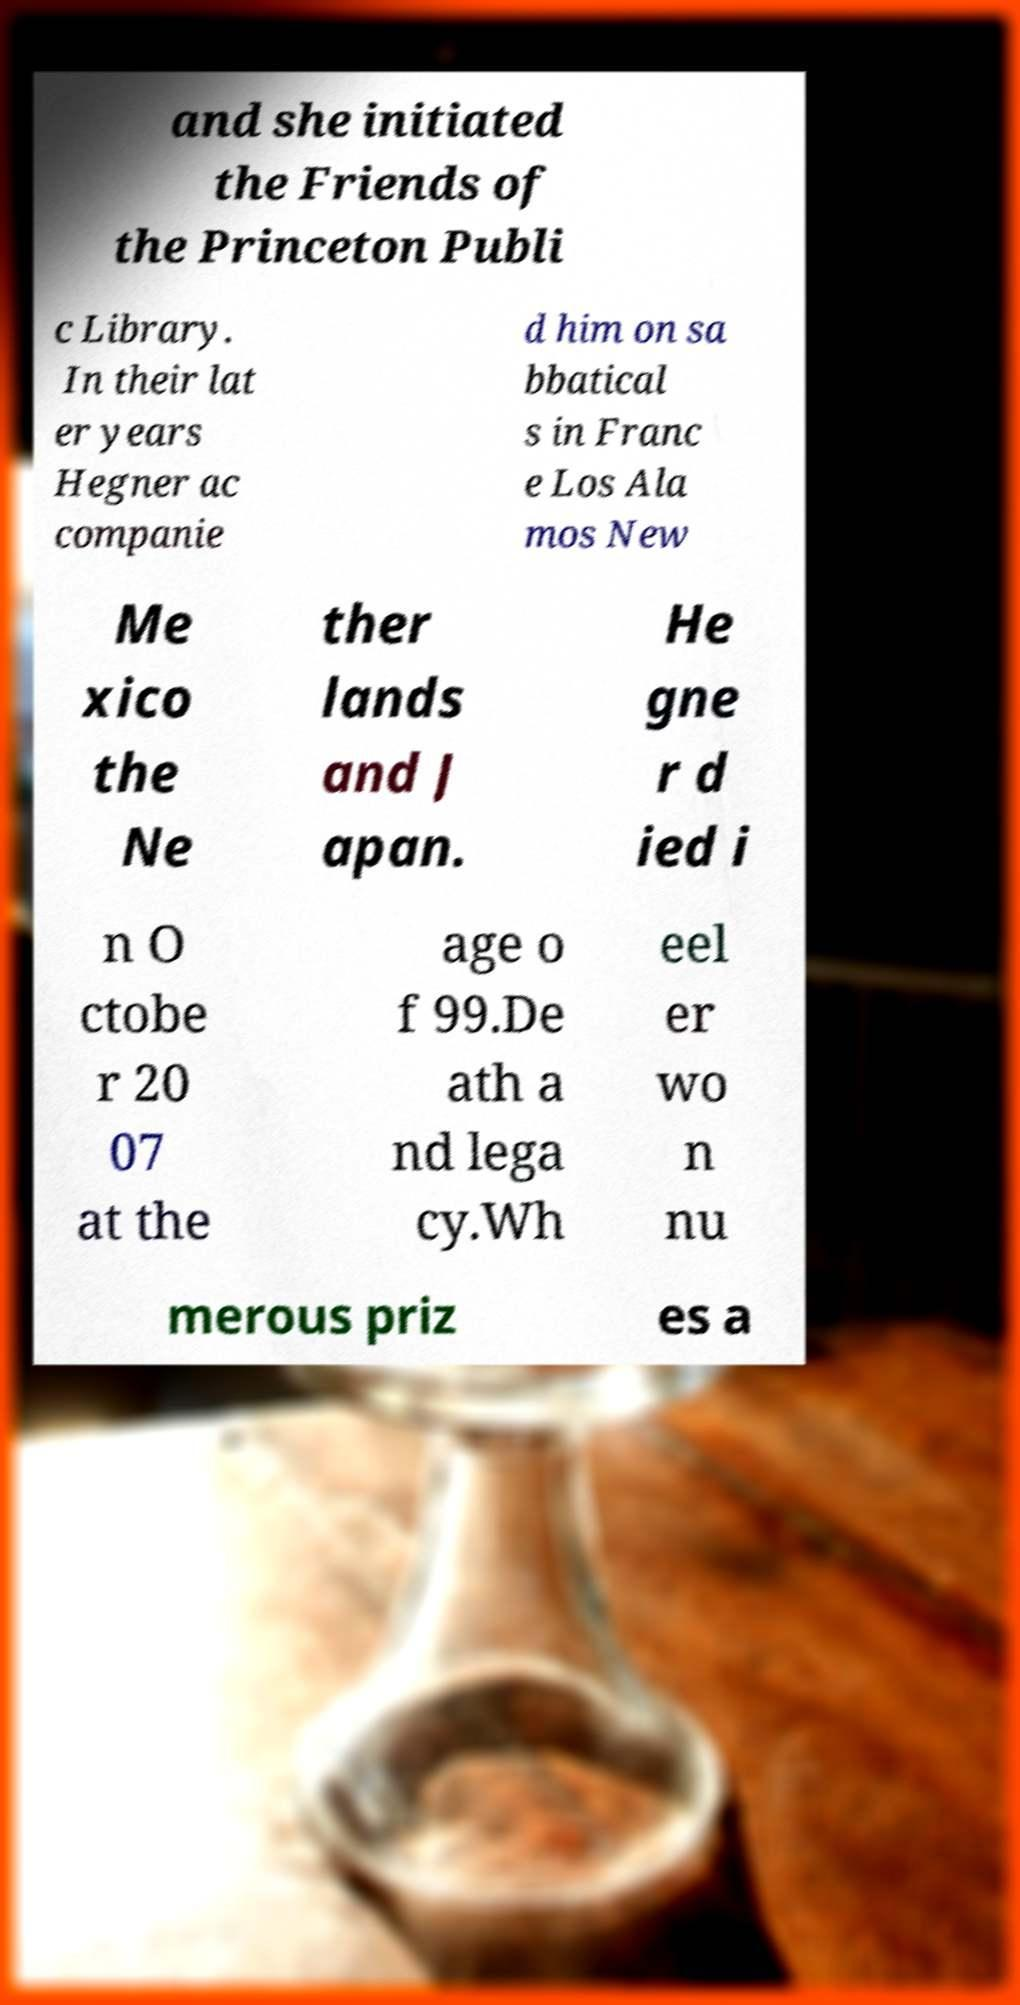There's text embedded in this image that I need extracted. Can you transcribe it verbatim? and she initiated the Friends of the Princeton Publi c Library. In their lat er years Hegner ac companie d him on sa bbatical s in Franc e Los Ala mos New Me xico the Ne ther lands and J apan. He gne r d ied i n O ctobe r 20 07 at the age o f 99.De ath a nd lega cy.Wh eel er wo n nu merous priz es a 